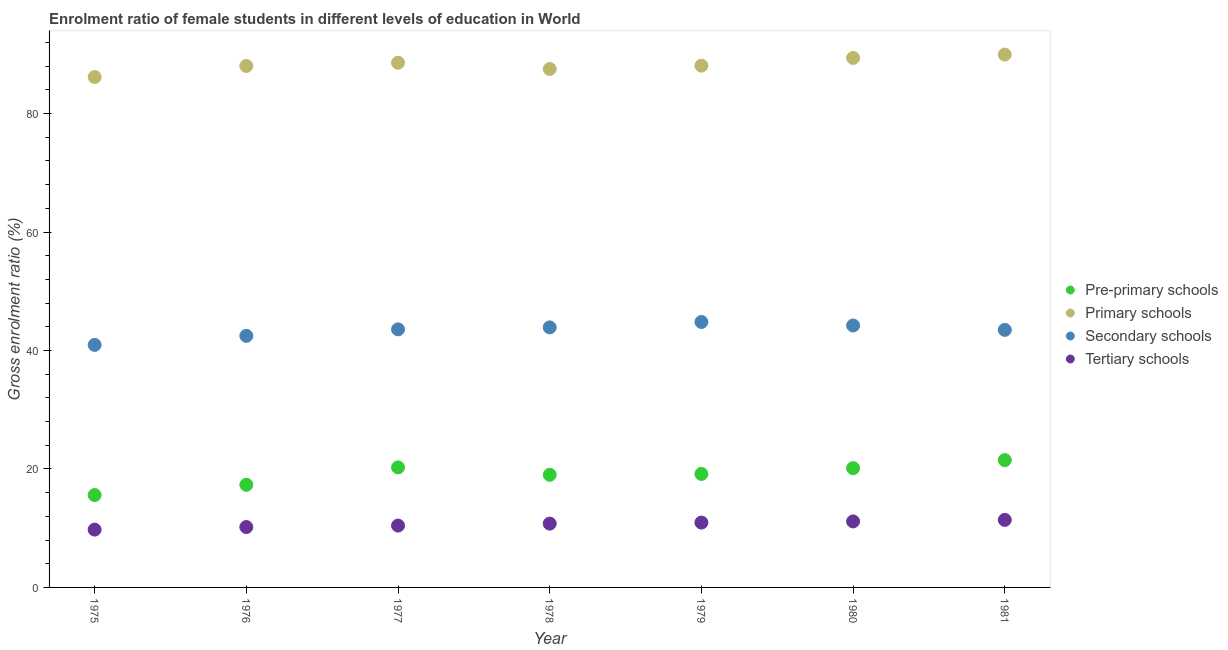How many different coloured dotlines are there?
Provide a short and direct response. 4. Is the number of dotlines equal to the number of legend labels?
Make the answer very short. Yes. What is the gross enrolment ratio(male) in pre-primary schools in 1977?
Offer a terse response. 20.26. Across all years, what is the maximum gross enrolment ratio(male) in primary schools?
Offer a very short reply. 89.96. Across all years, what is the minimum gross enrolment ratio(male) in pre-primary schools?
Provide a succinct answer. 15.6. In which year was the gross enrolment ratio(male) in pre-primary schools maximum?
Keep it short and to the point. 1981. In which year was the gross enrolment ratio(male) in primary schools minimum?
Give a very brief answer. 1975. What is the total gross enrolment ratio(male) in secondary schools in the graph?
Your answer should be compact. 303.42. What is the difference between the gross enrolment ratio(male) in pre-primary schools in 1975 and that in 1978?
Give a very brief answer. -3.42. What is the difference between the gross enrolment ratio(male) in tertiary schools in 1979 and the gross enrolment ratio(male) in secondary schools in 1976?
Give a very brief answer. -31.53. What is the average gross enrolment ratio(male) in secondary schools per year?
Make the answer very short. 43.35. In the year 1981, what is the difference between the gross enrolment ratio(male) in pre-primary schools and gross enrolment ratio(male) in tertiary schools?
Give a very brief answer. 10.09. In how many years, is the gross enrolment ratio(male) in pre-primary schools greater than 4 %?
Make the answer very short. 7. What is the ratio of the gross enrolment ratio(male) in secondary schools in 1975 to that in 1980?
Your answer should be very brief. 0.93. Is the gross enrolment ratio(male) in secondary schools in 1975 less than that in 1976?
Ensure brevity in your answer.  Yes. Is the difference between the gross enrolment ratio(male) in pre-primary schools in 1977 and 1980 greater than the difference between the gross enrolment ratio(male) in tertiary schools in 1977 and 1980?
Your response must be concise. Yes. What is the difference between the highest and the second highest gross enrolment ratio(male) in primary schools?
Ensure brevity in your answer.  0.57. What is the difference between the highest and the lowest gross enrolment ratio(male) in pre-primary schools?
Give a very brief answer. 5.9. Is the sum of the gross enrolment ratio(male) in primary schools in 1977 and 1978 greater than the maximum gross enrolment ratio(male) in secondary schools across all years?
Your response must be concise. Yes. Is it the case that in every year, the sum of the gross enrolment ratio(male) in tertiary schools and gross enrolment ratio(male) in primary schools is greater than the sum of gross enrolment ratio(male) in secondary schools and gross enrolment ratio(male) in pre-primary schools?
Provide a short and direct response. Yes. How many years are there in the graph?
Ensure brevity in your answer.  7. Are the values on the major ticks of Y-axis written in scientific E-notation?
Offer a terse response. No. Does the graph contain any zero values?
Your answer should be very brief. No. Does the graph contain grids?
Make the answer very short. No. Where does the legend appear in the graph?
Make the answer very short. Center right. How many legend labels are there?
Your answer should be compact. 4. How are the legend labels stacked?
Your response must be concise. Vertical. What is the title of the graph?
Provide a short and direct response. Enrolment ratio of female students in different levels of education in World. What is the label or title of the X-axis?
Provide a short and direct response. Year. What is the label or title of the Y-axis?
Make the answer very short. Gross enrolment ratio (%). What is the Gross enrolment ratio (%) of Pre-primary schools in 1975?
Ensure brevity in your answer.  15.6. What is the Gross enrolment ratio (%) of Primary schools in 1975?
Give a very brief answer. 86.18. What is the Gross enrolment ratio (%) in Secondary schools in 1975?
Give a very brief answer. 40.94. What is the Gross enrolment ratio (%) of Tertiary schools in 1975?
Ensure brevity in your answer.  9.76. What is the Gross enrolment ratio (%) of Pre-primary schools in 1976?
Provide a short and direct response. 17.33. What is the Gross enrolment ratio (%) of Primary schools in 1976?
Offer a very short reply. 88.04. What is the Gross enrolment ratio (%) of Secondary schools in 1976?
Offer a terse response. 42.48. What is the Gross enrolment ratio (%) in Tertiary schools in 1976?
Give a very brief answer. 10.2. What is the Gross enrolment ratio (%) in Pre-primary schools in 1977?
Your answer should be compact. 20.26. What is the Gross enrolment ratio (%) of Primary schools in 1977?
Ensure brevity in your answer.  88.58. What is the Gross enrolment ratio (%) of Secondary schools in 1977?
Your response must be concise. 43.57. What is the Gross enrolment ratio (%) of Tertiary schools in 1977?
Offer a very short reply. 10.44. What is the Gross enrolment ratio (%) in Pre-primary schools in 1978?
Your answer should be very brief. 19.01. What is the Gross enrolment ratio (%) in Primary schools in 1978?
Provide a short and direct response. 87.53. What is the Gross enrolment ratio (%) of Secondary schools in 1978?
Make the answer very short. 43.9. What is the Gross enrolment ratio (%) in Tertiary schools in 1978?
Your response must be concise. 10.77. What is the Gross enrolment ratio (%) in Pre-primary schools in 1979?
Your answer should be very brief. 19.16. What is the Gross enrolment ratio (%) of Primary schools in 1979?
Make the answer very short. 88.1. What is the Gross enrolment ratio (%) of Secondary schools in 1979?
Provide a succinct answer. 44.82. What is the Gross enrolment ratio (%) of Tertiary schools in 1979?
Keep it short and to the point. 10.95. What is the Gross enrolment ratio (%) of Pre-primary schools in 1980?
Give a very brief answer. 20.13. What is the Gross enrolment ratio (%) of Primary schools in 1980?
Your response must be concise. 89.4. What is the Gross enrolment ratio (%) in Secondary schools in 1980?
Offer a terse response. 44.22. What is the Gross enrolment ratio (%) in Tertiary schools in 1980?
Your answer should be compact. 11.14. What is the Gross enrolment ratio (%) in Pre-primary schools in 1981?
Offer a very short reply. 21.49. What is the Gross enrolment ratio (%) of Primary schools in 1981?
Provide a short and direct response. 89.96. What is the Gross enrolment ratio (%) of Secondary schools in 1981?
Your response must be concise. 43.48. What is the Gross enrolment ratio (%) of Tertiary schools in 1981?
Your answer should be compact. 11.4. Across all years, what is the maximum Gross enrolment ratio (%) of Pre-primary schools?
Give a very brief answer. 21.49. Across all years, what is the maximum Gross enrolment ratio (%) of Primary schools?
Offer a terse response. 89.96. Across all years, what is the maximum Gross enrolment ratio (%) of Secondary schools?
Your answer should be compact. 44.82. Across all years, what is the maximum Gross enrolment ratio (%) in Tertiary schools?
Ensure brevity in your answer.  11.4. Across all years, what is the minimum Gross enrolment ratio (%) of Pre-primary schools?
Give a very brief answer. 15.6. Across all years, what is the minimum Gross enrolment ratio (%) of Primary schools?
Ensure brevity in your answer.  86.18. Across all years, what is the minimum Gross enrolment ratio (%) of Secondary schools?
Make the answer very short. 40.94. Across all years, what is the minimum Gross enrolment ratio (%) of Tertiary schools?
Your answer should be very brief. 9.76. What is the total Gross enrolment ratio (%) in Pre-primary schools in the graph?
Provide a short and direct response. 132.99. What is the total Gross enrolment ratio (%) in Primary schools in the graph?
Ensure brevity in your answer.  617.79. What is the total Gross enrolment ratio (%) of Secondary schools in the graph?
Make the answer very short. 303.42. What is the total Gross enrolment ratio (%) in Tertiary schools in the graph?
Provide a succinct answer. 74.67. What is the difference between the Gross enrolment ratio (%) in Pre-primary schools in 1975 and that in 1976?
Provide a short and direct response. -1.73. What is the difference between the Gross enrolment ratio (%) in Primary schools in 1975 and that in 1976?
Your answer should be very brief. -1.87. What is the difference between the Gross enrolment ratio (%) of Secondary schools in 1975 and that in 1976?
Offer a terse response. -1.53. What is the difference between the Gross enrolment ratio (%) of Tertiary schools in 1975 and that in 1976?
Ensure brevity in your answer.  -0.44. What is the difference between the Gross enrolment ratio (%) in Pre-primary schools in 1975 and that in 1977?
Provide a short and direct response. -4.67. What is the difference between the Gross enrolment ratio (%) of Primary schools in 1975 and that in 1977?
Ensure brevity in your answer.  -2.41. What is the difference between the Gross enrolment ratio (%) in Secondary schools in 1975 and that in 1977?
Offer a terse response. -2.62. What is the difference between the Gross enrolment ratio (%) in Tertiary schools in 1975 and that in 1977?
Offer a terse response. -0.68. What is the difference between the Gross enrolment ratio (%) in Pre-primary schools in 1975 and that in 1978?
Ensure brevity in your answer.  -3.42. What is the difference between the Gross enrolment ratio (%) in Primary schools in 1975 and that in 1978?
Keep it short and to the point. -1.36. What is the difference between the Gross enrolment ratio (%) in Secondary schools in 1975 and that in 1978?
Provide a succinct answer. -2.96. What is the difference between the Gross enrolment ratio (%) in Tertiary schools in 1975 and that in 1978?
Your answer should be compact. -1.01. What is the difference between the Gross enrolment ratio (%) of Pre-primary schools in 1975 and that in 1979?
Ensure brevity in your answer.  -3.56. What is the difference between the Gross enrolment ratio (%) in Primary schools in 1975 and that in 1979?
Ensure brevity in your answer.  -1.92. What is the difference between the Gross enrolment ratio (%) of Secondary schools in 1975 and that in 1979?
Keep it short and to the point. -3.87. What is the difference between the Gross enrolment ratio (%) in Tertiary schools in 1975 and that in 1979?
Offer a terse response. -1.19. What is the difference between the Gross enrolment ratio (%) in Pre-primary schools in 1975 and that in 1980?
Your answer should be compact. -4.54. What is the difference between the Gross enrolment ratio (%) of Primary schools in 1975 and that in 1980?
Your response must be concise. -3.22. What is the difference between the Gross enrolment ratio (%) of Secondary schools in 1975 and that in 1980?
Make the answer very short. -3.28. What is the difference between the Gross enrolment ratio (%) of Tertiary schools in 1975 and that in 1980?
Ensure brevity in your answer.  -1.38. What is the difference between the Gross enrolment ratio (%) in Pre-primary schools in 1975 and that in 1981?
Provide a succinct answer. -5.9. What is the difference between the Gross enrolment ratio (%) of Primary schools in 1975 and that in 1981?
Your answer should be very brief. -3.79. What is the difference between the Gross enrolment ratio (%) in Secondary schools in 1975 and that in 1981?
Make the answer very short. -2.54. What is the difference between the Gross enrolment ratio (%) of Tertiary schools in 1975 and that in 1981?
Keep it short and to the point. -1.64. What is the difference between the Gross enrolment ratio (%) of Pre-primary schools in 1976 and that in 1977?
Offer a terse response. -2.94. What is the difference between the Gross enrolment ratio (%) of Primary schools in 1976 and that in 1977?
Your answer should be very brief. -0.54. What is the difference between the Gross enrolment ratio (%) in Secondary schools in 1976 and that in 1977?
Give a very brief answer. -1.09. What is the difference between the Gross enrolment ratio (%) of Tertiary schools in 1976 and that in 1977?
Offer a very short reply. -0.25. What is the difference between the Gross enrolment ratio (%) of Pre-primary schools in 1976 and that in 1978?
Your answer should be very brief. -1.69. What is the difference between the Gross enrolment ratio (%) of Primary schools in 1976 and that in 1978?
Keep it short and to the point. 0.51. What is the difference between the Gross enrolment ratio (%) in Secondary schools in 1976 and that in 1978?
Provide a succinct answer. -1.43. What is the difference between the Gross enrolment ratio (%) in Tertiary schools in 1976 and that in 1978?
Make the answer very short. -0.58. What is the difference between the Gross enrolment ratio (%) in Pre-primary schools in 1976 and that in 1979?
Offer a very short reply. -1.83. What is the difference between the Gross enrolment ratio (%) in Primary schools in 1976 and that in 1979?
Offer a terse response. -0.06. What is the difference between the Gross enrolment ratio (%) in Secondary schools in 1976 and that in 1979?
Offer a very short reply. -2.34. What is the difference between the Gross enrolment ratio (%) of Tertiary schools in 1976 and that in 1979?
Offer a very short reply. -0.75. What is the difference between the Gross enrolment ratio (%) of Pre-primary schools in 1976 and that in 1980?
Your response must be concise. -2.81. What is the difference between the Gross enrolment ratio (%) in Primary schools in 1976 and that in 1980?
Keep it short and to the point. -1.36. What is the difference between the Gross enrolment ratio (%) in Secondary schools in 1976 and that in 1980?
Provide a succinct answer. -1.75. What is the difference between the Gross enrolment ratio (%) in Tertiary schools in 1976 and that in 1980?
Provide a short and direct response. -0.95. What is the difference between the Gross enrolment ratio (%) in Pre-primary schools in 1976 and that in 1981?
Give a very brief answer. -4.16. What is the difference between the Gross enrolment ratio (%) of Primary schools in 1976 and that in 1981?
Make the answer very short. -1.92. What is the difference between the Gross enrolment ratio (%) of Secondary schools in 1976 and that in 1981?
Your answer should be compact. -1.01. What is the difference between the Gross enrolment ratio (%) in Tertiary schools in 1976 and that in 1981?
Your answer should be compact. -1.21. What is the difference between the Gross enrolment ratio (%) in Pre-primary schools in 1977 and that in 1978?
Offer a very short reply. 1.25. What is the difference between the Gross enrolment ratio (%) of Secondary schools in 1977 and that in 1978?
Your answer should be very brief. -0.33. What is the difference between the Gross enrolment ratio (%) in Tertiary schools in 1977 and that in 1978?
Offer a terse response. -0.33. What is the difference between the Gross enrolment ratio (%) in Pre-primary schools in 1977 and that in 1979?
Your response must be concise. 1.1. What is the difference between the Gross enrolment ratio (%) of Primary schools in 1977 and that in 1979?
Give a very brief answer. 0.49. What is the difference between the Gross enrolment ratio (%) of Secondary schools in 1977 and that in 1979?
Ensure brevity in your answer.  -1.25. What is the difference between the Gross enrolment ratio (%) of Tertiary schools in 1977 and that in 1979?
Offer a terse response. -0.51. What is the difference between the Gross enrolment ratio (%) in Pre-primary schools in 1977 and that in 1980?
Your response must be concise. 0.13. What is the difference between the Gross enrolment ratio (%) in Primary schools in 1977 and that in 1980?
Provide a succinct answer. -0.81. What is the difference between the Gross enrolment ratio (%) of Secondary schools in 1977 and that in 1980?
Ensure brevity in your answer.  -0.65. What is the difference between the Gross enrolment ratio (%) in Tertiary schools in 1977 and that in 1980?
Ensure brevity in your answer.  -0.7. What is the difference between the Gross enrolment ratio (%) in Pre-primary schools in 1977 and that in 1981?
Your answer should be compact. -1.23. What is the difference between the Gross enrolment ratio (%) of Primary schools in 1977 and that in 1981?
Keep it short and to the point. -1.38. What is the difference between the Gross enrolment ratio (%) of Secondary schools in 1977 and that in 1981?
Make the answer very short. 0.09. What is the difference between the Gross enrolment ratio (%) in Tertiary schools in 1977 and that in 1981?
Ensure brevity in your answer.  -0.96. What is the difference between the Gross enrolment ratio (%) in Pre-primary schools in 1978 and that in 1979?
Your answer should be compact. -0.15. What is the difference between the Gross enrolment ratio (%) in Primary schools in 1978 and that in 1979?
Provide a succinct answer. -0.56. What is the difference between the Gross enrolment ratio (%) of Secondary schools in 1978 and that in 1979?
Offer a terse response. -0.91. What is the difference between the Gross enrolment ratio (%) in Tertiary schools in 1978 and that in 1979?
Provide a succinct answer. -0.18. What is the difference between the Gross enrolment ratio (%) of Pre-primary schools in 1978 and that in 1980?
Your answer should be very brief. -1.12. What is the difference between the Gross enrolment ratio (%) of Primary schools in 1978 and that in 1980?
Make the answer very short. -1.86. What is the difference between the Gross enrolment ratio (%) of Secondary schools in 1978 and that in 1980?
Ensure brevity in your answer.  -0.32. What is the difference between the Gross enrolment ratio (%) in Tertiary schools in 1978 and that in 1980?
Your response must be concise. -0.37. What is the difference between the Gross enrolment ratio (%) of Pre-primary schools in 1978 and that in 1981?
Provide a short and direct response. -2.48. What is the difference between the Gross enrolment ratio (%) in Primary schools in 1978 and that in 1981?
Ensure brevity in your answer.  -2.43. What is the difference between the Gross enrolment ratio (%) in Secondary schools in 1978 and that in 1981?
Provide a short and direct response. 0.42. What is the difference between the Gross enrolment ratio (%) of Tertiary schools in 1978 and that in 1981?
Offer a terse response. -0.63. What is the difference between the Gross enrolment ratio (%) in Pre-primary schools in 1979 and that in 1980?
Provide a succinct answer. -0.97. What is the difference between the Gross enrolment ratio (%) in Primary schools in 1979 and that in 1980?
Provide a succinct answer. -1.3. What is the difference between the Gross enrolment ratio (%) of Secondary schools in 1979 and that in 1980?
Your answer should be compact. 0.59. What is the difference between the Gross enrolment ratio (%) in Tertiary schools in 1979 and that in 1980?
Offer a terse response. -0.19. What is the difference between the Gross enrolment ratio (%) of Pre-primary schools in 1979 and that in 1981?
Your answer should be compact. -2.33. What is the difference between the Gross enrolment ratio (%) of Primary schools in 1979 and that in 1981?
Ensure brevity in your answer.  -1.86. What is the difference between the Gross enrolment ratio (%) in Secondary schools in 1979 and that in 1981?
Keep it short and to the point. 1.33. What is the difference between the Gross enrolment ratio (%) in Tertiary schools in 1979 and that in 1981?
Offer a terse response. -0.45. What is the difference between the Gross enrolment ratio (%) in Pre-primary schools in 1980 and that in 1981?
Your answer should be compact. -1.36. What is the difference between the Gross enrolment ratio (%) in Primary schools in 1980 and that in 1981?
Provide a short and direct response. -0.57. What is the difference between the Gross enrolment ratio (%) of Secondary schools in 1980 and that in 1981?
Provide a succinct answer. 0.74. What is the difference between the Gross enrolment ratio (%) in Tertiary schools in 1980 and that in 1981?
Make the answer very short. -0.26. What is the difference between the Gross enrolment ratio (%) in Pre-primary schools in 1975 and the Gross enrolment ratio (%) in Primary schools in 1976?
Keep it short and to the point. -72.44. What is the difference between the Gross enrolment ratio (%) in Pre-primary schools in 1975 and the Gross enrolment ratio (%) in Secondary schools in 1976?
Make the answer very short. -26.88. What is the difference between the Gross enrolment ratio (%) of Pre-primary schools in 1975 and the Gross enrolment ratio (%) of Tertiary schools in 1976?
Offer a very short reply. 5.4. What is the difference between the Gross enrolment ratio (%) of Primary schools in 1975 and the Gross enrolment ratio (%) of Secondary schools in 1976?
Ensure brevity in your answer.  43.7. What is the difference between the Gross enrolment ratio (%) in Primary schools in 1975 and the Gross enrolment ratio (%) in Tertiary schools in 1976?
Provide a succinct answer. 75.98. What is the difference between the Gross enrolment ratio (%) of Secondary schools in 1975 and the Gross enrolment ratio (%) of Tertiary schools in 1976?
Provide a succinct answer. 30.75. What is the difference between the Gross enrolment ratio (%) of Pre-primary schools in 1975 and the Gross enrolment ratio (%) of Primary schools in 1977?
Provide a succinct answer. -72.99. What is the difference between the Gross enrolment ratio (%) in Pre-primary schools in 1975 and the Gross enrolment ratio (%) in Secondary schools in 1977?
Give a very brief answer. -27.97. What is the difference between the Gross enrolment ratio (%) in Pre-primary schools in 1975 and the Gross enrolment ratio (%) in Tertiary schools in 1977?
Offer a terse response. 5.15. What is the difference between the Gross enrolment ratio (%) of Primary schools in 1975 and the Gross enrolment ratio (%) of Secondary schools in 1977?
Provide a succinct answer. 42.61. What is the difference between the Gross enrolment ratio (%) of Primary schools in 1975 and the Gross enrolment ratio (%) of Tertiary schools in 1977?
Your answer should be compact. 75.73. What is the difference between the Gross enrolment ratio (%) in Secondary schools in 1975 and the Gross enrolment ratio (%) in Tertiary schools in 1977?
Give a very brief answer. 30.5. What is the difference between the Gross enrolment ratio (%) of Pre-primary schools in 1975 and the Gross enrolment ratio (%) of Primary schools in 1978?
Offer a very short reply. -71.94. What is the difference between the Gross enrolment ratio (%) in Pre-primary schools in 1975 and the Gross enrolment ratio (%) in Secondary schools in 1978?
Your answer should be compact. -28.31. What is the difference between the Gross enrolment ratio (%) of Pre-primary schools in 1975 and the Gross enrolment ratio (%) of Tertiary schools in 1978?
Provide a succinct answer. 4.82. What is the difference between the Gross enrolment ratio (%) in Primary schools in 1975 and the Gross enrolment ratio (%) in Secondary schools in 1978?
Keep it short and to the point. 42.27. What is the difference between the Gross enrolment ratio (%) in Primary schools in 1975 and the Gross enrolment ratio (%) in Tertiary schools in 1978?
Ensure brevity in your answer.  75.4. What is the difference between the Gross enrolment ratio (%) in Secondary schools in 1975 and the Gross enrolment ratio (%) in Tertiary schools in 1978?
Keep it short and to the point. 30.17. What is the difference between the Gross enrolment ratio (%) of Pre-primary schools in 1975 and the Gross enrolment ratio (%) of Primary schools in 1979?
Keep it short and to the point. -72.5. What is the difference between the Gross enrolment ratio (%) in Pre-primary schools in 1975 and the Gross enrolment ratio (%) in Secondary schools in 1979?
Provide a short and direct response. -29.22. What is the difference between the Gross enrolment ratio (%) in Pre-primary schools in 1975 and the Gross enrolment ratio (%) in Tertiary schools in 1979?
Provide a succinct answer. 4.65. What is the difference between the Gross enrolment ratio (%) in Primary schools in 1975 and the Gross enrolment ratio (%) in Secondary schools in 1979?
Provide a succinct answer. 41.36. What is the difference between the Gross enrolment ratio (%) of Primary schools in 1975 and the Gross enrolment ratio (%) of Tertiary schools in 1979?
Give a very brief answer. 75.23. What is the difference between the Gross enrolment ratio (%) of Secondary schools in 1975 and the Gross enrolment ratio (%) of Tertiary schools in 1979?
Your answer should be compact. 29.99. What is the difference between the Gross enrolment ratio (%) of Pre-primary schools in 1975 and the Gross enrolment ratio (%) of Primary schools in 1980?
Your response must be concise. -73.8. What is the difference between the Gross enrolment ratio (%) of Pre-primary schools in 1975 and the Gross enrolment ratio (%) of Secondary schools in 1980?
Offer a very short reply. -28.63. What is the difference between the Gross enrolment ratio (%) of Pre-primary schools in 1975 and the Gross enrolment ratio (%) of Tertiary schools in 1980?
Give a very brief answer. 4.45. What is the difference between the Gross enrolment ratio (%) of Primary schools in 1975 and the Gross enrolment ratio (%) of Secondary schools in 1980?
Offer a terse response. 41.95. What is the difference between the Gross enrolment ratio (%) of Primary schools in 1975 and the Gross enrolment ratio (%) of Tertiary schools in 1980?
Make the answer very short. 75.03. What is the difference between the Gross enrolment ratio (%) of Secondary schools in 1975 and the Gross enrolment ratio (%) of Tertiary schools in 1980?
Provide a short and direct response. 29.8. What is the difference between the Gross enrolment ratio (%) in Pre-primary schools in 1975 and the Gross enrolment ratio (%) in Primary schools in 1981?
Your answer should be very brief. -74.37. What is the difference between the Gross enrolment ratio (%) in Pre-primary schools in 1975 and the Gross enrolment ratio (%) in Secondary schools in 1981?
Your answer should be very brief. -27.89. What is the difference between the Gross enrolment ratio (%) of Pre-primary schools in 1975 and the Gross enrolment ratio (%) of Tertiary schools in 1981?
Offer a very short reply. 4.19. What is the difference between the Gross enrolment ratio (%) of Primary schools in 1975 and the Gross enrolment ratio (%) of Secondary schools in 1981?
Provide a succinct answer. 42.69. What is the difference between the Gross enrolment ratio (%) in Primary schools in 1975 and the Gross enrolment ratio (%) in Tertiary schools in 1981?
Give a very brief answer. 74.77. What is the difference between the Gross enrolment ratio (%) in Secondary schools in 1975 and the Gross enrolment ratio (%) in Tertiary schools in 1981?
Offer a very short reply. 29.54. What is the difference between the Gross enrolment ratio (%) in Pre-primary schools in 1976 and the Gross enrolment ratio (%) in Primary schools in 1977?
Ensure brevity in your answer.  -71.26. What is the difference between the Gross enrolment ratio (%) of Pre-primary schools in 1976 and the Gross enrolment ratio (%) of Secondary schools in 1977?
Keep it short and to the point. -26.24. What is the difference between the Gross enrolment ratio (%) of Pre-primary schools in 1976 and the Gross enrolment ratio (%) of Tertiary schools in 1977?
Make the answer very short. 6.88. What is the difference between the Gross enrolment ratio (%) in Primary schools in 1976 and the Gross enrolment ratio (%) in Secondary schools in 1977?
Your answer should be compact. 44.47. What is the difference between the Gross enrolment ratio (%) in Primary schools in 1976 and the Gross enrolment ratio (%) in Tertiary schools in 1977?
Offer a terse response. 77.6. What is the difference between the Gross enrolment ratio (%) in Secondary schools in 1976 and the Gross enrolment ratio (%) in Tertiary schools in 1977?
Offer a very short reply. 32.03. What is the difference between the Gross enrolment ratio (%) of Pre-primary schools in 1976 and the Gross enrolment ratio (%) of Primary schools in 1978?
Provide a short and direct response. -70.21. What is the difference between the Gross enrolment ratio (%) in Pre-primary schools in 1976 and the Gross enrolment ratio (%) in Secondary schools in 1978?
Your answer should be very brief. -26.58. What is the difference between the Gross enrolment ratio (%) in Pre-primary schools in 1976 and the Gross enrolment ratio (%) in Tertiary schools in 1978?
Give a very brief answer. 6.56. What is the difference between the Gross enrolment ratio (%) in Primary schools in 1976 and the Gross enrolment ratio (%) in Secondary schools in 1978?
Offer a terse response. 44.14. What is the difference between the Gross enrolment ratio (%) of Primary schools in 1976 and the Gross enrolment ratio (%) of Tertiary schools in 1978?
Provide a short and direct response. 77.27. What is the difference between the Gross enrolment ratio (%) of Secondary schools in 1976 and the Gross enrolment ratio (%) of Tertiary schools in 1978?
Provide a short and direct response. 31.7. What is the difference between the Gross enrolment ratio (%) in Pre-primary schools in 1976 and the Gross enrolment ratio (%) in Primary schools in 1979?
Offer a terse response. -70.77. What is the difference between the Gross enrolment ratio (%) of Pre-primary schools in 1976 and the Gross enrolment ratio (%) of Secondary schools in 1979?
Your answer should be compact. -27.49. What is the difference between the Gross enrolment ratio (%) in Pre-primary schools in 1976 and the Gross enrolment ratio (%) in Tertiary schools in 1979?
Make the answer very short. 6.38. What is the difference between the Gross enrolment ratio (%) in Primary schools in 1976 and the Gross enrolment ratio (%) in Secondary schools in 1979?
Provide a succinct answer. 43.22. What is the difference between the Gross enrolment ratio (%) in Primary schools in 1976 and the Gross enrolment ratio (%) in Tertiary schools in 1979?
Your response must be concise. 77.09. What is the difference between the Gross enrolment ratio (%) in Secondary schools in 1976 and the Gross enrolment ratio (%) in Tertiary schools in 1979?
Give a very brief answer. 31.53. What is the difference between the Gross enrolment ratio (%) of Pre-primary schools in 1976 and the Gross enrolment ratio (%) of Primary schools in 1980?
Make the answer very short. -72.07. What is the difference between the Gross enrolment ratio (%) of Pre-primary schools in 1976 and the Gross enrolment ratio (%) of Secondary schools in 1980?
Make the answer very short. -26.9. What is the difference between the Gross enrolment ratio (%) in Pre-primary schools in 1976 and the Gross enrolment ratio (%) in Tertiary schools in 1980?
Ensure brevity in your answer.  6.18. What is the difference between the Gross enrolment ratio (%) in Primary schools in 1976 and the Gross enrolment ratio (%) in Secondary schools in 1980?
Give a very brief answer. 43.82. What is the difference between the Gross enrolment ratio (%) in Primary schools in 1976 and the Gross enrolment ratio (%) in Tertiary schools in 1980?
Provide a short and direct response. 76.9. What is the difference between the Gross enrolment ratio (%) in Secondary schools in 1976 and the Gross enrolment ratio (%) in Tertiary schools in 1980?
Ensure brevity in your answer.  31.33. What is the difference between the Gross enrolment ratio (%) in Pre-primary schools in 1976 and the Gross enrolment ratio (%) in Primary schools in 1981?
Make the answer very short. -72.63. What is the difference between the Gross enrolment ratio (%) in Pre-primary schools in 1976 and the Gross enrolment ratio (%) in Secondary schools in 1981?
Your response must be concise. -26.15. What is the difference between the Gross enrolment ratio (%) in Pre-primary schools in 1976 and the Gross enrolment ratio (%) in Tertiary schools in 1981?
Give a very brief answer. 5.93. What is the difference between the Gross enrolment ratio (%) of Primary schools in 1976 and the Gross enrolment ratio (%) of Secondary schools in 1981?
Offer a terse response. 44.56. What is the difference between the Gross enrolment ratio (%) in Primary schools in 1976 and the Gross enrolment ratio (%) in Tertiary schools in 1981?
Offer a terse response. 76.64. What is the difference between the Gross enrolment ratio (%) in Secondary schools in 1976 and the Gross enrolment ratio (%) in Tertiary schools in 1981?
Keep it short and to the point. 31.07. What is the difference between the Gross enrolment ratio (%) in Pre-primary schools in 1977 and the Gross enrolment ratio (%) in Primary schools in 1978?
Your response must be concise. -67.27. What is the difference between the Gross enrolment ratio (%) in Pre-primary schools in 1977 and the Gross enrolment ratio (%) in Secondary schools in 1978?
Offer a terse response. -23.64. What is the difference between the Gross enrolment ratio (%) of Pre-primary schools in 1977 and the Gross enrolment ratio (%) of Tertiary schools in 1978?
Ensure brevity in your answer.  9.49. What is the difference between the Gross enrolment ratio (%) of Primary schools in 1977 and the Gross enrolment ratio (%) of Secondary schools in 1978?
Ensure brevity in your answer.  44.68. What is the difference between the Gross enrolment ratio (%) of Primary schools in 1977 and the Gross enrolment ratio (%) of Tertiary schools in 1978?
Offer a terse response. 77.81. What is the difference between the Gross enrolment ratio (%) of Secondary schools in 1977 and the Gross enrolment ratio (%) of Tertiary schools in 1978?
Provide a short and direct response. 32.8. What is the difference between the Gross enrolment ratio (%) of Pre-primary schools in 1977 and the Gross enrolment ratio (%) of Primary schools in 1979?
Provide a short and direct response. -67.83. What is the difference between the Gross enrolment ratio (%) of Pre-primary schools in 1977 and the Gross enrolment ratio (%) of Secondary schools in 1979?
Make the answer very short. -24.55. What is the difference between the Gross enrolment ratio (%) of Pre-primary schools in 1977 and the Gross enrolment ratio (%) of Tertiary schools in 1979?
Provide a short and direct response. 9.31. What is the difference between the Gross enrolment ratio (%) of Primary schools in 1977 and the Gross enrolment ratio (%) of Secondary schools in 1979?
Your answer should be very brief. 43.77. What is the difference between the Gross enrolment ratio (%) in Primary schools in 1977 and the Gross enrolment ratio (%) in Tertiary schools in 1979?
Offer a very short reply. 77.63. What is the difference between the Gross enrolment ratio (%) in Secondary schools in 1977 and the Gross enrolment ratio (%) in Tertiary schools in 1979?
Give a very brief answer. 32.62. What is the difference between the Gross enrolment ratio (%) in Pre-primary schools in 1977 and the Gross enrolment ratio (%) in Primary schools in 1980?
Your answer should be very brief. -69.13. What is the difference between the Gross enrolment ratio (%) in Pre-primary schools in 1977 and the Gross enrolment ratio (%) in Secondary schools in 1980?
Ensure brevity in your answer.  -23.96. What is the difference between the Gross enrolment ratio (%) of Pre-primary schools in 1977 and the Gross enrolment ratio (%) of Tertiary schools in 1980?
Provide a succinct answer. 9.12. What is the difference between the Gross enrolment ratio (%) of Primary schools in 1977 and the Gross enrolment ratio (%) of Secondary schools in 1980?
Keep it short and to the point. 44.36. What is the difference between the Gross enrolment ratio (%) in Primary schools in 1977 and the Gross enrolment ratio (%) in Tertiary schools in 1980?
Provide a succinct answer. 77.44. What is the difference between the Gross enrolment ratio (%) in Secondary schools in 1977 and the Gross enrolment ratio (%) in Tertiary schools in 1980?
Keep it short and to the point. 32.42. What is the difference between the Gross enrolment ratio (%) in Pre-primary schools in 1977 and the Gross enrolment ratio (%) in Primary schools in 1981?
Your answer should be very brief. -69.7. What is the difference between the Gross enrolment ratio (%) in Pre-primary schools in 1977 and the Gross enrolment ratio (%) in Secondary schools in 1981?
Offer a very short reply. -23.22. What is the difference between the Gross enrolment ratio (%) in Pre-primary schools in 1977 and the Gross enrolment ratio (%) in Tertiary schools in 1981?
Your answer should be compact. 8.86. What is the difference between the Gross enrolment ratio (%) of Primary schools in 1977 and the Gross enrolment ratio (%) of Secondary schools in 1981?
Your response must be concise. 45.1. What is the difference between the Gross enrolment ratio (%) in Primary schools in 1977 and the Gross enrolment ratio (%) in Tertiary schools in 1981?
Give a very brief answer. 77.18. What is the difference between the Gross enrolment ratio (%) in Secondary schools in 1977 and the Gross enrolment ratio (%) in Tertiary schools in 1981?
Provide a succinct answer. 32.17. What is the difference between the Gross enrolment ratio (%) in Pre-primary schools in 1978 and the Gross enrolment ratio (%) in Primary schools in 1979?
Keep it short and to the point. -69.08. What is the difference between the Gross enrolment ratio (%) in Pre-primary schools in 1978 and the Gross enrolment ratio (%) in Secondary schools in 1979?
Offer a terse response. -25.8. What is the difference between the Gross enrolment ratio (%) in Pre-primary schools in 1978 and the Gross enrolment ratio (%) in Tertiary schools in 1979?
Offer a terse response. 8.06. What is the difference between the Gross enrolment ratio (%) in Primary schools in 1978 and the Gross enrolment ratio (%) in Secondary schools in 1979?
Your answer should be compact. 42.72. What is the difference between the Gross enrolment ratio (%) in Primary schools in 1978 and the Gross enrolment ratio (%) in Tertiary schools in 1979?
Make the answer very short. 76.58. What is the difference between the Gross enrolment ratio (%) in Secondary schools in 1978 and the Gross enrolment ratio (%) in Tertiary schools in 1979?
Ensure brevity in your answer.  32.95. What is the difference between the Gross enrolment ratio (%) of Pre-primary schools in 1978 and the Gross enrolment ratio (%) of Primary schools in 1980?
Offer a very short reply. -70.38. What is the difference between the Gross enrolment ratio (%) in Pre-primary schools in 1978 and the Gross enrolment ratio (%) in Secondary schools in 1980?
Offer a very short reply. -25.21. What is the difference between the Gross enrolment ratio (%) in Pre-primary schools in 1978 and the Gross enrolment ratio (%) in Tertiary schools in 1980?
Offer a terse response. 7.87. What is the difference between the Gross enrolment ratio (%) in Primary schools in 1978 and the Gross enrolment ratio (%) in Secondary schools in 1980?
Your answer should be compact. 43.31. What is the difference between the Gross enrolment ratio (%) of Primary schools in 1978 and the Gross enrolment ratio (%) of Tertiary schools in 1980?
Your answer should be compact. 76.39. What is the difference between the Gross enrolment ratio (%) of Secondary schools in 1978 and the Gross enrolment ratio (%) of Tertiary schools in 1980?
Your answer should be very brief. 32.76. What is the difference between the Gross enrolment ratio (%) in Pre-primary schools in 1978 and the Gross enrolment ratio (%) in Primary schools in 1981?
Provide a short and direct response. -70.95. What is the difference between the Gross enrolment ratio (%) in Pre-primary schools in 1978 and the Gross enrolment ratio (%) in Secondary schools in 1981?
Provide a succinct answer. -24.47. What is the difference between the Gross enrolment ratio (%) of Pre-primary schools in 1978 and the Gross enrolment ratio (%) of Tertiary schools in 1981?
Keep it short and to the point. 7.61. What is the difference between the Gross enrolment ratio (%) in Primary schools in 1978 and the Gross enrolment ratio (%) in Secondary schools in 1981?
Your answer should be compact. 44.05. What is the difference between the Gross enrolment ratio (%) in Primary schools in 1978 and the Gross enrolment ratio (%) in Tertiary schools in 1981?
Ensure brevity in your answer.  76.13. What is the difference between the Gross enrolment ratio (%) in Secondary schools in 1978 and the Gross enrolment ratio (%) in Tertiary schools in 1981?
Make the answer very short. 32.5. What is the difference between the Gross enrolment ratio (%) in Pre-primary schools in 1979 and the Gross enrolment ratio (%) in Primary schools in 1980?
Keep it short and to the point. -70.24. What is the difference between the Gross enrolment ratio (%) of Pre-primary schools in 1979 and the Gross enrolment ratio (%) of Secondary schools in 1980?
Offer a terse response. -25.06. What is the difference between the Gross enrolment ratio (%) of Pre-primary schools in 1979 and the Gross enrolment ratio (%) of Tertiary schools in 1980?
Your answer should be compact. 8.01. What is the difference between the Gross enrolment ratio (%) in Primary schools in 1979 and the Gross enrolment ratio (%) in Secondary schools in 1980?
Provide a succinct answer. 43.87. What is the difference between the Gross enrolment ratio (%) in Primary schools in 1979 and the Gross enrolment ratio (%) in Tertiary schools in 1980?
Provide a succinct answer. 76.95. What is the difference between the Gross enrolment ratio (%) of Secondary schools in 1979 and the Gross enrolment ratio (%) of Tertiary schools in 1980?
Provide a succinct answer. 33.67. What is the difference between the Gross enrolment ratio (%) in Pre-primary schools in 1979 and the Gross enrolment ratio (%) in Primary schools in 1981?
Make the answer very short. -70.8. What is the difference between the Gross enrolment ratio (%) in Pre-primary schools in 1979 and the Gross enrolment ratio (%) in Secondary schools in 1981?
Your answer should be compact. -24.32. What is the difference between the Gross enrolment ratio (%) of Pre-primary schools in 1979 and the Gross enrolment ratio (%) of Tertiary schools in 1981?
Keep it short and to the point. 7.76. What is the difference between the Gross enrolment ratio (%) of Primary schools in 1979 and the Gross enrolment ratio (%) of Secondary schools in 1981?
Ensure brevity in your answer.  44.61. What is the difference between the Gross enrolment ratio (%) of Primary schools in 1979 and the Gross enrolment ratio (%) of Tertiary schools in 1981?
Provide a short and direct response. 76.7. What is the difference between the Gross enrolment ratio (%) of Secondary schools in 1979 and the Gross enrolment ratio (%) of Tertiary schools in 1981?
Ensure brevity in your answer.  33.41. What is the difference between the Gross enrolment ratio (%) of Pre-primary schools in 1980 and the Gross enrolment ratio (%) of Primary schools in 1981?
Give a very brief answer. -69.83. What is the difference between the Gross enrolment ratio (%) in Pre-primary schools in 1980 and the Gross enrolment ratio (%) in Secondary schools in 1981?
Offer a terse response. -23.35. What is the difference between the Gross enrolment ratio (%) in Pre-primary schools in 1980 and the Gross enrolment ratio (%) in Tertiary schools in 1981?
Your answer should be compact. 8.73. What is the difference between the Gross enrolment ratio (%) in Primary schools in 1980 and the Gross enrolment ratio (%) in Secondary schools in 1981?
Make the answer very short. 45.91. What is the difference between the Gross enrolment ratio (%) in Primary schools in 1980 and the Gross enrolment ratio (%) in Tertiary schools in 1981?
Provide a short and direct response. 77.99. What is the difference between the Gross enrolment ratio (%) of Secondary schools in 1980 and the Gross enrolment ratio (%) of Tertiary schools in 1981?
Provide a succinct answer. 32.82. What is the average Gross enrolment ratio (%) in Pre-primary schools per year?
Your answer should be very brief. 19. What is the average Gross enrolment ratio (%) in Primary schools per year?
Provide a short and direct response. 88.26. What is the average Gross enrolment ratio (%) in Secondary schools per year?
Make the answer very short. 43.35. What is the average Gross enrolment ratio (%) in Tertiary schools per year?
Give a very brief answer. 10.67. In the year 1975, what is the difference between the Gross enrolment ratio (%) of Pre-primary schools and Gross enrolment ratio (%) of Primary schools?
Your response must be concise. -70.58. In the year 1975, what is the difference between the Gross enrolment ratio (%) in Pre-primary schools and Gross enrolment ratio (%) in Secondary schools?
Your answer should be very brief. -25.35. In the year 1975, what is the difference between the Gross enrolment ratio (%) of Pre-primary schools and Gross enrolment ratio (%) of Tertiary schools?
Your answer should be very brief. 5.84. In the year 1975, what is the difference between the Gross enrolment ratio (%) of Primary schools and Gross enrolment ratio (%) of Secondary schools?
Your answer should be compact. 45.23. In the year 1975, what is the difference between the Gross enrolment ratio (%) in Primary schools and Gross enrolment ratio (%) in Tertiary schools?
Your response must be concise. 76.42. In the year 1975, what is the difference between the Gross enrolment ratio (%) of Secondary schools and Gross enrolment ratio (%) of Tertiary schools?
Give a very brief answer. 31.18. In the year 1976, what is the difference between the Gross enrolment ratio (%) in Pre-primary schools and Gross enrolment ratio (%) in Primary schools?
Make the answer very short. -70.71. In the year 1976, what is the difference between the Gross enrolment ratio (%) in Pre-primary schools and Gross enrolment ratio (%) in Secondary schools?
Give a very brief answer. -25.15. In the year 1976, what is the difference between the Gross enrolment ratio (%) of Pre-primary schools and Gross enrolment ratio (%) of Tertiary schools?
Make the answer very short. 7.13. In the year 1976, what is the difference between the Gross enrolment ratio (%) in Primary schools and Gross enrolment ratio (%) in Secondary schools?
Your response must be concise. 45.57. In the year 1976, what is the difference between the Gross enrolment ratio (%) in Primary schools and Gross enrolment ratio (%) in Tertiary schools?
Keep it short and to the point. 77.85. In the year 1976, what is the difference between the Gross enrolment ratio (%) of Secondary schools and Gross enrolment ratio (%) of Tertiary schools?
Your answer should be very brief. 32.28. In the year 1977, what is the difference between the Gross enrolment ratio (%) of Pre-primary schools and Gross enrolment ratio (%) of Primary schools?
Offer a terse response. -68.32. In the year 1977, what is the difference between the Gross enrolment ratio (%) of Pre-primary schools and Gross enrolment ratio (%) of Secondary schools?
Keep it short and to the point. -23.31. In the year 1977, what is the difference between the Gross enrolment ratio (%) of Pre-primary schools and Gross enrolment ratio (%) of Tertiary schools?
Your answer should be compact. 9.82. In the year 1977, what is the difference between the Gross enrolment ratio (%) in Primary schools and Gross enrolment ratio (%) in Secondary schools?
Your answer should be very brief. 45.02. In the year 1977, what is the difference between the Gross enrolment ratio (%) in Primary schools and Gross enrolment ratio (%) in Tertiary schools?
Provide a short and direct response. 78.14. In the year 1977, what is the difference between the Gross enrolment ratio (%) of Secondary schools and Gross enrolment ratio (%) of Tertiary schools?
Provide a succinct answer. 33.12. In the year 1978, what is the difference between the Gross enrolment ratio (%) in Pre-primary schools and Gross enrolment ratio (%) in Primary schools?
Make the answer very short. -68.52. In the year 1978, what is the difference between the Gross enrolment ratio (%) in Pre-primary schools and Gross enrolment ratio (%) in Secondary schools?
Make the answer very short. -24.89. In the year 1978, what is the difference between the Gross enrolment ratio (%) of Pre-primary schools and Gross enrolment ratio (%) of Tertiary schools?
Provide a succinct answer. 8.24. In the year 1978, what is the difference between the Gross enrolment ratio (%) in Primary schools and Gross enrolment ratio (%) in Secondary schools?
Your answer should be compact. 43.63. In the year 1978, what is the difference between the Gross enrolment ratio (%) in Primary schools and Gross enrolment ratio (%) in Tertiary schools?
Offer a terse response. 76.76. In the year 1978, what is the difference between the Gross enrolment ratio (%) in Secondary schools and Gross enrolment ratio (%) in Tertiary schools?
Provide a short and direct response. 33.13. In the year 1979, what is the difference between the Gross enrolment ratio (%) of Pre-primary schools and Gross enrolment ratio (%) of Primary schools?
Provide a short and direct response. -68.94. In the year 1979, what is the difference between the Gross enrolment ratio (%) of Pre-primary schools and Gross enrolment ratio (%) of Secondary schools?
Your answer should be very brief. -25.66. In the year 1979, what is the difference between the Gross enrolment ratio (%) in Pre-primary schools and Gross enrolment ratio (%) in Tertiary schools?
Offer a very short reply. 8.21. In the year 1979, what is the difference between the Gross enrolment ratio (%) in Primary schools and Gross enrolment ratio (%) in Secondary schools?
Make the answer very short. 43.28. In the year 1979, what is the difference between the Gross enrolment ratio (%) in Primary schools and Gross enrolment ratio (%) in Tertiary schools?
Give a very brief answer. 77.15. In the year 1979, what is the difference between the Gross enrolment ratio (%) in Secondary schools and Gross enrolment ratio (%) in Tertiary schools?
Your answer should be compact. 33.87. In the year 1980, what is the difference between the Gross enrolment ratio (%) of Pre-primary schools and Gross enrolment ratio (%) of Primary schools?
Your answer should be very brief. -69.26. In the year 1980, what is the difference between the Gross enrolment ratio (%) in Pre-primary schools and Gross enrolment ratio (%) in Secondary schools?
Provide a short and direct response. -24.09. In the year 1980, what is the difference between the Gross enrolment ratio (%) in Pre-primary schools and Gross enrolment ratio (%) in Tertiary schools?
Ensure brevity in your answer.  8.99. In the year 1980, what is the difference between the Gross enrolment ratio (%) of Primary schools and Gross enrolment ratio (%) of Secondary schools?
Offer a terse response. 45.17. In the year 1980, what is the difference between the Gross enrolment ratio (%) in Primary schools and Gross enrolment ratio (%) in Tertiary schools?
Keep it short and to the point. 78.25. In the year 1980, what is the difference between the Gross enrolment ratio (%) in Secondary schools and Gross enrolment ratio (%) in Tertiary schools?
Provide a short and direct response. 33.08. In the year 1981, what is the difference between the Gross enrolment ratio (%) of Pre-primary schools and Gross enrolment ratio (%) of Primary schools?
Make the answer very short. -68.47. In the year 1981, what is the difference between the Gross enrolment ratio (%) of Pre-primary schools and Gross enrolment ratio (%) of Secondary schools?
Give a very brief answer. -21.99. In the year 1981, what is the difference between the Gross enrolment ratio (%) in Pre-primary schools and Gross enrolment ratio (%) in Tertiary schools?
Keep it short and to the point. 10.09. In the year 1981, what is the difference between the Gross enrolment ratio (%) in Primary schools and Gross enrolment ratio (%) in Secondary schools?
Provide a short and direct response. 46.48. In the year 1981, what is the difference between the Gross enrolment ratio (%) in Primary schools and Gross enrolment ratio (%) in Tertiary schools?
Offer a very short reply. 78.56. In the year 1981, what is the difference between the Gross enrolment ratio (%) of Secondary schools and Gross enrolment ratio (%) of Tertiary schools?
Offer a terse response. 32.08. What is the ratio of the Gross enrolment ratio (%) in Pre-primary schools in 1975 to that in 1976?
Provide a succinct answer. 0.9. What is the ratio of the Gross enrolment ratio (%) in Primary schools in 1975 to that in 1976?
Offer a very short reply. 0.98. What is the ratio of the Gross enrolment ratio (%) of Secondary schools in 1975 to that in 1976?
Give a very brief answer. 0.96. What is the ratio of the Gross enrolment ratio (%) in Tertiary schools in 1975 to that in 1976?
Offer a very short reply. 0.96. What is the ratio of the Gross enrolment ratio (%) of Pre-primary schools in 1975 to that in 1977?
Make the answer very short. 0.77. What is the ratio of the Gross enrolment ratio (%) in Primary schools in 1975 to that in 1977?
Offer a terse response. 0.97. What is the ratio of the Gross enrolment ratio (%) of Secondary schools in 1975 to that in 1977?
Keep it short and to the point. 0.94. What is the ratio of the Gross enrolment ratio (%) in Tertiary schools in 1975 to that in 1977?
Offer a terse response. 0.93. What is the ratio of the Gross enrolment ratio (%) of Pre-primary schools in 1975 to that in 1978?
Keep it short and to the point. 0.82. What is the ratio of the Gross enrolment ratio (%) of Primary schools in 1975 to that in 1978?
Give a very brief answer. 0.98. What is the ratio of the Gross enrolment ratio (%) of Secondary schools in 1975 to that in 1978?
Your response must be concise. 0.93. What is the ratio of the Gross enrolment ratio (%) in Tertiary schools in 1975 to that in 1978?
Offer a very short reply. 0.91. What is the ratio of the Gross enrolment ratio (%) in Pre-primary schools in 1975 to that in 1979?
Ensure brevity in your answer.  0.81. What is the ratio of the Gross enrolment ratio (%) of Primary schools in 1975 to that in 1979?
Offer a very short reply. 0.98. What is the ratio of the Gross enrolment ratio (%) of Secondary schools in 1975 to that in 1979?
Your answer should be very brief. 0.91. What is the ratio of the Gross enrolment ratio (%) of Tertiary schools in 1975 to that in 1979?
Your response must be concise. 0.89. What is the ratio of the Gross enrolment ratio (%) in Pre-primary schools in 1975 to that in 1980?
Your response must be concise. 0.77. What is the ratio of the Gross enrolment ratio (%) in Secondary schools in 1975 to that in 1980?
Provide a succinct answer. 0.93. What is the ratio of the Gross enrolment ratio (%) of Tertiary schools in 1975 to that in 1980?
Make the answer very short. 0.88. What is the ratio of the Gross enrolment ratio (%) in Pre-primary schools in 1975 to that in 1981?
Provide a short and direct response. 0.73. What is the ratio of the Gross enrolment ratio (%) in Primary schools in 1975 to that in 1981?
Make the answer very short. 0.96. What is the ratio of the Gross enrolment ratio (%) in Secondary schools in 1975 to that in 1981?
Ensure brevity in your answer.  0.94. What is the ratio of the Gross enrolment ratio (%) of Tertiary schools in 1975 to that in 1981?
Offer a very short reply. 0.86. What is the ratio of the Gross enrolment ratio (%) of Pre-primary schools in 1976 to that in 1977?
Your response must be concise. 0.86. What is the ratio of the Gross enrolment ratio (%) in Secondary schools in 1976 to that in 1977?
Provide a short and direct response. 0.97. What is the ratio of the Gross enrolment ratio (%) of Tertiary schools in 1976 to that in 1977?
Ensure brevity in your answer.  0.98. What is the ratio of the Gross enrolment ratio (%) of Pre-primary schools in 1976 to that in 1978?
Provide a succinct answer. 0.91. What is the ratio of the Gross enrolment ratio (%) of Secondary schools in 1976 to that in 1978?
Ensure brevity in your answer.  0.97. What is the ratio of the Gross enrolment ratio (%) in Tertiary schools in 1976 to that in 1978?
Your response must be concise. 0.95. What is the ratio of the Gross enrolment ratio (%) in Pre-primary schools in 1976 to that in 1979?
Make the answer very short. 0.9. What is the ratio of the Gross enrolment ratio (%) in Secondary schools in 1976 to that in 1979?
Provide a succinct answer. 0.95. What is the ratio of the Gross enrolment ratio (%) of Tertiary schools in 1976 to that in 1979?
Provide a succinct answer. 0.93. What is the ratio of the Gross enrolment ratio (%) of Pre-primary schools in 1976 to that in 1980?
Your answer should be very brief. 0.86. What is the ratio of the Gross enrolment ratio (%) of Primary schools in 1976 to that in 1980?
Your answer should be compact. 0.98. What is the ratio of the Gross enrolment ratio (%) of Secondary schools in 1976 to that in 1980?
Provide a succinct answer. 0.96. What is the ratio of the Gross enrolment ratio (%) of Tertiary schools in 1976 to that in 1980?
Provide a short and direct response. 0.91. What is the ratio of the Gross enrolment ratio (%) of Pre-primary schools in 1976 to that in 1981?
Offer a terse response. 0.81. What is the ratio of the Gross enrolment ratio (%) of Primary schools in 1976 to that in 1981?
Give a very brief answer. 0.98. What is the ratio of the Gross enrolment ratio (%) in Secondary schools in 1976 to that in 1981?
Your response must be concise. 0.98. What is the ratio of the Gross enrolment ratio (%) in Tertiary schools in 1976 to that in 1981?
Keep it short and to the point. 0.89. What is the ratio of the Gross enrolment ratio (%) in Pre-primary schools in 1977 to that in 1978?
Keep it short and to the point. 1.07. What is the ratio of the Gross enrolment ratio (%) in Primary schools in 1977 to that in 1978?
Provide a short and direct response. 1.01. What is the ratio of the Gross enrolment ratio (%) of Secondary schools in 1977 to that in 1978?
Give a very brief answer. 0.99. What is the ratio of the Gross enrolment ratio (%) of Tertiary schools in 1977 to that in 1978?
Keep it short and to the point. 0.97. What is the ratio of the Gross enrolment ratio (%) in Pre-primary schools in 1977 to that in 1979?
Make the answer very short. 1.06. What is the ratio of the Gross enrolment ratio (%) in Primary schools in 1977 to that in 1979?
Your answer should be very brief. 1.01. What is the ratio of the Gross enrolment ratio (%) of Secondary schools in 1977 to that in 1979?
Your answer should be compact. 0.97. What is the ratio of the Gross enrolment ratio (%) of Tertiary schools in 1977 to that in 1979?
Offer a terse response. 0.95. What is the ratio of the Gross enrolment ratio (%) of Primary schools in 1977 to that in 1980?
Your answer should be very brief. 0.99. What is the ratio of the Gross enrolment ratio (%) in Secondary schools in 1977 to that in 1980?
Offer a terse response. 0.99. What is the ratio of the Gross enrolment ratio (%) of Tertiary schools in 1977 to that in 1980?
Keep it short and to the point. 0.94. What is the ratio of the Gross enrolment ratio (%) in Pre-primary schools in 1977 to that in 1981?
Your answer should be compact. 0.94. What is the ratio of the Gross enrolment ratio (%) in Primary schools in 1977 to that in 1981?
Give a very brief answer. 0.98. What is the ratio of the Gross enrolment ratio (%) of Secondary schools in 1977 to that in 1981?
Your answer should be very brief. 1. What is the ratio of the Gross enrolment ratio (%) of Tertiary schools in 1977 to that in 1981?
Make the answer very short. 0.92. What is the ratio of the Gross enrolment ratio (%) of Primary schools in 1978 to that in 1979?
Provide a short and direct response. 0.99. What is the ratio of the Gross enrolment ratio (%) in Secondary schools in 1978 to that in 1979?
Make the answer very short. 0.98. What is the ratio of the Gross enrolment ratio (%) in Tertiary schools in 1978 to that in 1979?
Provide a succinct answer. 0.98. What is the ratio of the Gross enrolment ratio (%) of Primary schools in 1978 to that in 1980?
Keep it short and to the point. 0.98. What is the ratio of the Gross enrolment ratio (%) in Secondary schools in 1978 to that in 1980?
Ensure brevity in your answer.  0.99. What is the ratio of the Gross enrolment ratio (%) in Tertiary schools in 1978 to that in 1980?
Your answer should be compact. 0.97. What is the ratio of the Gross enrolment ratio (%) of Pre-primary schools in 1978 to that in 1981?
Ensure brevity in your answer.  0.88. What is the ratio of the Gross enrolment ratio (%) of Primary schools in 1978 to that in 1981?
Keep it short and to the point. 0.97. What is the ratio of the Gross enrolment ratio (%) of Secondary schools in 1978 to that in 1981?
Ensure brevity in your answer.  1.01. What is the ratio of the Gross enrolment ratio (%) of Tertiary schools in 1978 to that in 1981?
Give a very brief answer. 0.94. What is the ratio of the Gross enrolment ratio (%) of Pre-primary schools in 1979 to that in 1980?
Make the answer very short. 0.95. What is the ratio of the Gross enrolment ratio (%) in Primary schools in 1979 to that in 1980?
Offer a terse response. 0.99. What is the ratio of the Gross enrolment ratio (%) of Secondary schools in 1979 to that in 1980?
Your response must be concise. 1.01. What is the ratio of the Gross enrolment ratio (%) of Tertiary schools in 1979 to that in 1980?
Give a very brief answer. 0.98. What is the ratio of the Gross enrolment ratio (%) of Pre-primary schools in 1979 to that in 1981?
Give a very brief answer. 0.89. What is the ratio of the Gross enrolment ratio (%) of Primary schools in 1979 to that in 1981?
Provide a succinct answer. 0.98. What is the ratio of the Gross enrolment ratio (%) of Secondary schools in 1979 to that in 1981?
Make the answer very short. 1.03. What is the ratio of the Gross enrolment ratio (%) in Tertiary schools in 1979 to that in 1981?
Make the answer very short. 0.96. What is the ratio of the Gross enrolment ratio (%) in Pre-primary schools in 1980 to that in 1981?
Keep it short and to the point. 0.94. What is the ratio of the Gross enrolment ratio (%) in Primary schools in 1980 to that in 1981?
Make the answer very short. 0.99. What is the ratio of the Gross enrolment ratio (%) of Secondary schools in 1980 to that in 1981?
Your answer should be very brief. 1.02. What is the ratio of the Gross enrolment ratio (%) in Tertiary schools in 1980 to that in 1981?
Provide a short and direct response. 0.98. What is the difference between the highest and the second highest Gross enrolment ratio (%) in Pre-primary schools?
Offer a terse response. 1.23. What is the difference between the highest and the second highest Gross enrolment ratio (%) in Primary schools?
Your answer should be very brief. 0.57. What is the difference between the highest and the second highest Gross enrolment ratio (%) of Secondary schools?
Offer a terse response. 0.59. What is the difference between the highest and the second highest Gross enrolment ratio (%) in Tertiary schools?
Offer a very short reply. 0.26. What is the difference between the highest and the lowest Gross enrolment ratio (%) of Pre-primary schools?
Keep it short and to the point. 5.9. What is the difference between the highest and the lowest Gross enrolment ratio (%) in Primary schools?
Your response must be concise. 3.79. What is the difference between the highest and the lowest Gross enrolment ratio (%) in Secondary schools?
Ensure brevity in your answer.  3.87. What is the difference between the highest and the lowest Gross enrolment ratio (%) in Tertiary schools?
Provide a short and direct response. 1.64. 